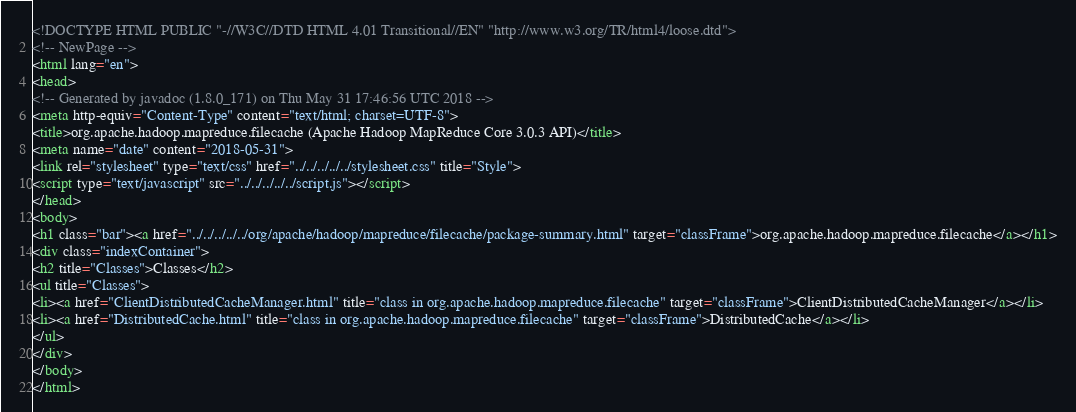<code> <loc_0><loc_0><loc_500><loc_500><_HTML_><!DOCTYPE HTML PUBLIC "-//W3C//DTD HTML 4.01 Transitional//EN" "http://www.w3.org/TR/html4/loose.dtd">
<!-- NewPage -->
<html lang="en">
<head>
<!-- Generated by javadoc (1.8.0_171) on Thu May 31 17:46:56 UTC 2018 -->
<meta http-equiv="Content-Type" content="text/html; charset=UTF-8">
<title>org.apache.hadoop.mapreduce.filecache (Apache Hadoop MapReduce Core 3.0.3 API)</title>
<meta name="date" content="2018-05-31">
<link rel="stylesheet" type="text/css" href="../../../../../stylesheet.css" title="Style">
<script type="text/javascript" src="../../../../../script.js"></script>
</head>
<body>
<h1 class="bar"><a href="../../../../../org/apache/hadoop/mapreduce/filecache/package-summary.html" target="classFrame">org.apache.hadoop.mapreduce.filecache</a></h1>
<div class="indexContainer">
<h2 title="Classes">Classes</h2>
<ul title="Classes">
<li><a href="ClientDistributedCacheManager.html" title="class in org.apache.hadoop.mapreduce.filecache" target="classFrame">ClientDistributedCacheManager</a></li>
<li><a href="DistributedCache.html" title="class in org.apache.hadoop.mapreduce.filecache" target="classFrame">DistributedCache</a></li>
</ul>
</div>
</body>
</html>
</code> 